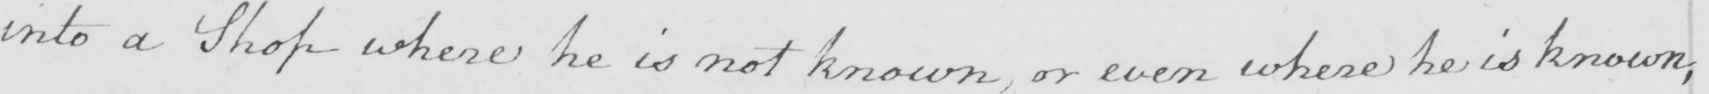What does this handwritten line say? into a Shop where he is not known or even where he is known , 